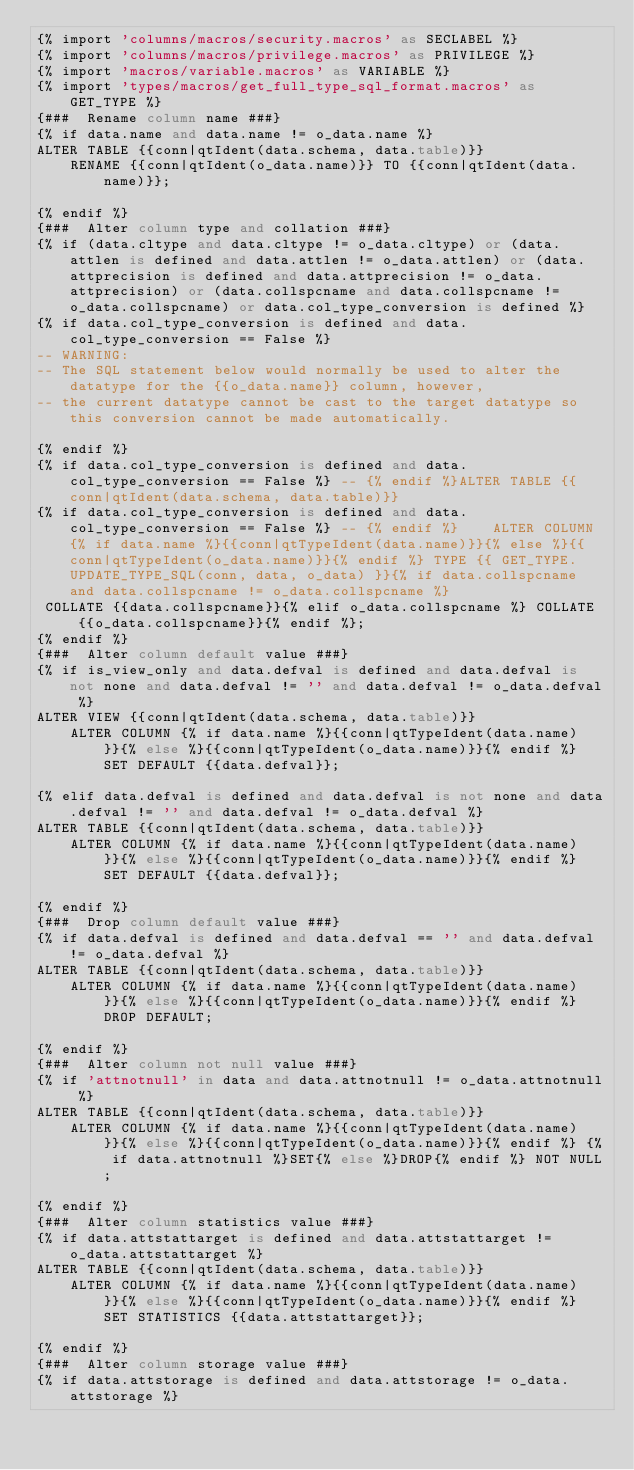Convert code to text. <code><loc_0><loc_0><loc_500><loc_500><_SQL_>{% import 'columns/macros/security.macros' as SECLABEL %}
{% import 'columns/macros/privilege.macros' as PRIVILEGE %}
{% import 'macros/variable.macros' as VARIABLE %}
{% import 'types/macros/get_full_type_sql_format.macros' as GET_TYPE %}
{###  Rename column name ###}
{% if data.name and data.name != o_data.name %}
ALTER TABLE {{conn|qtIdent(data.schema, data.table)}}
    RENAME {{conn|qtIdent(o_data.name)}} TO {{conn|qtIdent(data.name)}};

{% endif %}
{###  Alter column type and collation ###}
{% if (data.cltype and data.cltype != o_data.cltype) or (data.attlen is defined and data.attlen != o_data.attlen) or (data.attprecision is defined and data.attprecision != o_data.attprecision) or (data.collspcname and data.collspcname != o_data.collspcname) or data.col_type_conversion is defined %}
{% if data.col_type_conversion is defined and data.col_type_conversion == False %}
-- WARNING:
-- The SQL statement below would normally be used to alter the datatype for the {{o_data.name}} column, however,
-- the current datatype cannot be cast to the target datatype so this conversion cannot be made automatically.

{% endif %}
{% if data.col_type_conversion is defined and data.col_type_conversion == False %} -- {% endif %}ALTER TABLE {{conn|qtIdent(data.schema, data.table)}}
{% if data.col_type_conversion is defined and data.col_type_conversion == False %} -- {% endif %}    ALTER COLUMN {% if data.name %}{{conn|qtTypeIdent(data.name)}}{% else %}{{conn|qtTypeIdent(o_data.name)}}{% endif %} TYPE {{ GET_TYPE.UPDATE_TYPE_SQL(conn, data, o_data) }}{% if data.collspcname and data.collspcname != o_data.collspcname %}
 COLLATE {{data.collspcname}}{% elif o_data.collspcname %} COLLATE {{o_data.collspcname}}{% endif %};
{% endif %}
{###  Alter column default value ###}
{% if is_view_only and data.defval is defined and data.defval is not none and data.defval != '' and data.defval != o_data.defval %}
ALTER VIEW {{conn|qtIdent(data.schema, data.table)}}
    ALTER COLUMN {% if data.name %}{{conn|qtTypeIdent(data.name)}}{% else %}{{conn|qtTypeIdent(o_data.name)}}{% endif %} SET DEFAULT {{data.defval}};

{% elif data.defval is defined and data.defval is not none and data.defval != '' and data.defval != o_data.defval %}
ALTER TABLE {{conn|qtIdent(data.schema, data.table)}}
    ALTER COLUMN {% if data.name %}{{conn|qtTypeIdent(data.name)}}{% else %}{{conn|qtTypeIdent(o_data.name)}}{% endif %} SET DEFAULT {{data.defval}};

{% endif %}
{###  Drop column default value ###}
{% if data.defval is defined and data.defval == '' and data.defval != o_data.defval %}
ALTER TABLE {{conn|qtIdent(data.schema, data.table)}}
    ALTER COLUMN {% if data.name %}{{conn|qtTypeIdent(data.name)}}{% else %}{{conn|qtTypeIdent(o_data.name)}}{% endif %} DROP DEFAULT;

{% endif %}
{###  Alter column not null value ###}
{% if 'attnotnull' in data and data.attnotnull != o_data.attnotnull %}
ALTER TABLE {{conn|qtIdent(data.schema, data.table)}}
    ALTER COLUMN {% if data.name %}{{conn|qtTypeIdent(data.name)}}{% else %}{{conn|qtTypeIdent(o_data.name)}}{% endif %} {% if data.attnotnull %}SET{% else %}DROP{% endif %} NOT NULL;

{% endif %}
{###  Alter column statistics value ###}
{% if data.attstattarget is defined and data.attstattarget != o_data.attstattarget %}
ALTER TABLE {{conn|qtIdent(data.schema, data.table)}}
    ALTER COLUMN {% if data.name %}{{conn|qtTypeIdent(data.name)}}{% else %}{{conn|qtTypeIdent(o_data.name)}}{% endif %} SET STATISTICS {{data.attstattarget}};

{% endif %}
{###  Alter column storage value ###}
{% if data.attstorage is defined and data.attstorage != o_data.attstorage %}</code> 